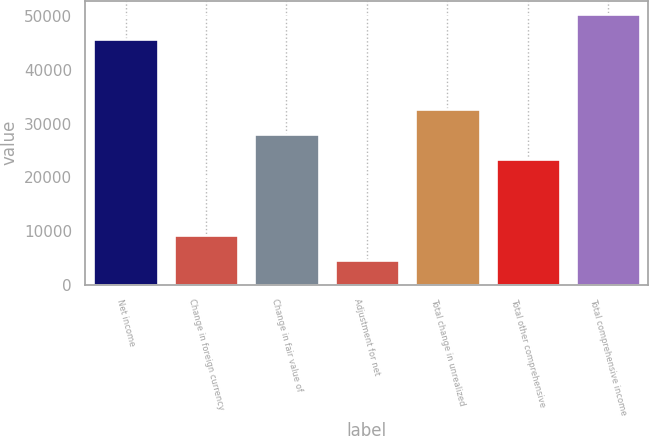Convert chart to OTSL. <chart><loc_0><loc_0><loc_500><loc_500><bar_chart><fcel>Net income<fcel>Change in foreign currency<fcel>Change in fair value of<fcel>Adjustment for net<fcel>Total change in unrealized<fcel>Total other comprehensive<fcel>Total comprehensive income<nl><fcel>45687<fcel>9338.8<fcel>28002.4<fcel>4672.9<fcel>32668.3<fcel>23336.5<fcel>50352.9<nl></chart> 